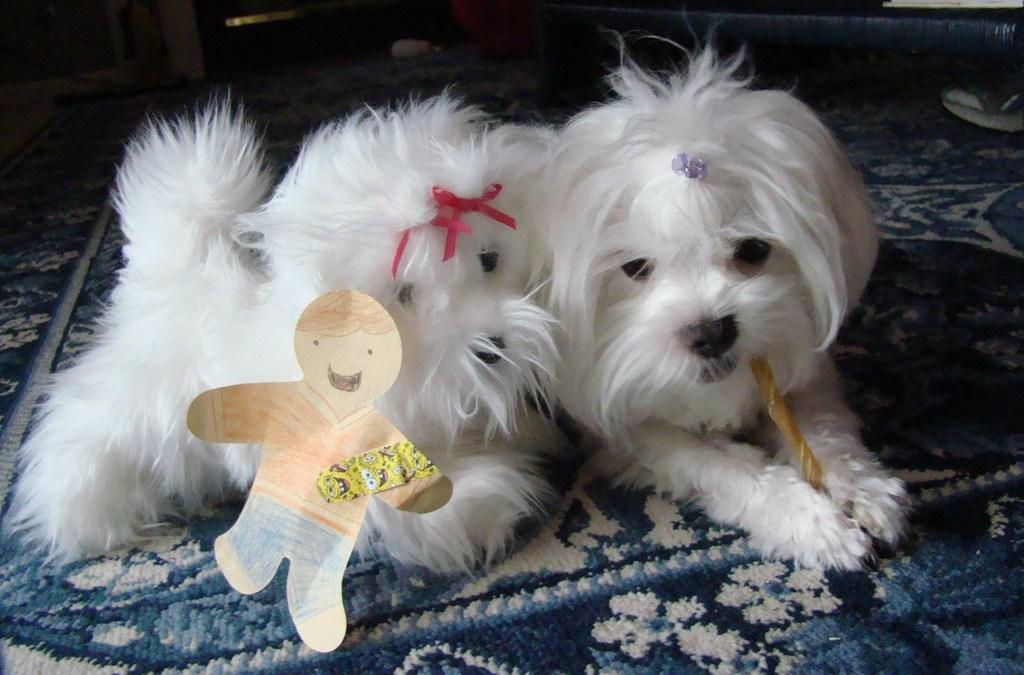How many animals are present in the image? There are two puppies in the image. What are the puppies sitting on? The puppies are sitting on a mat. What accessories are the puppies wearing? The puppies have ribbons and stickers on them. What type of rifle can be seen in the image? There is no rifle present in the image; it features two puppies sitting on a mat with ribbons and stickers on them. What is being served for lunch in the image? There is no indication of lunch being served in the image; it only shows two puppies sitting on a mat. 